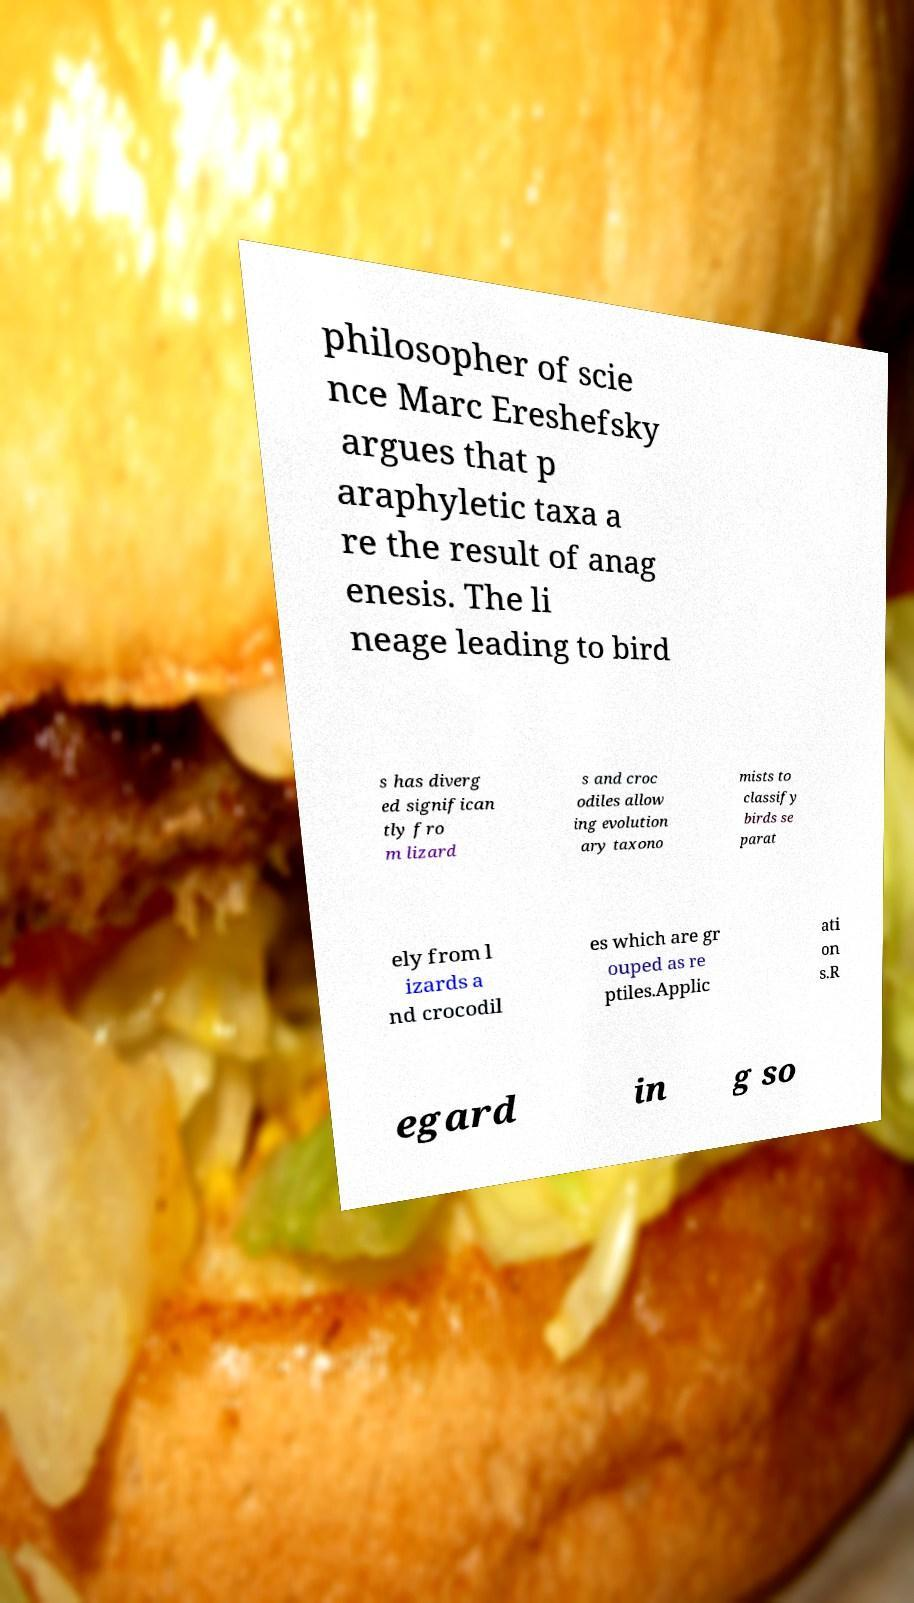I need the written content from this picture converted into text. Can you do that? philosopher of scie nce Marc Ereshefsky argues that p araphyletic taxa a re the result of anag enesis. The li neage leading to bird s has diverg ed significan tly fro m lizard s and croc odiles allow ing evolution ary taxono mists to classify birds se parat ely from l izards a nd crocodil es which are gr ouped as re ptiles.Applic ati on s.R egard in g so 